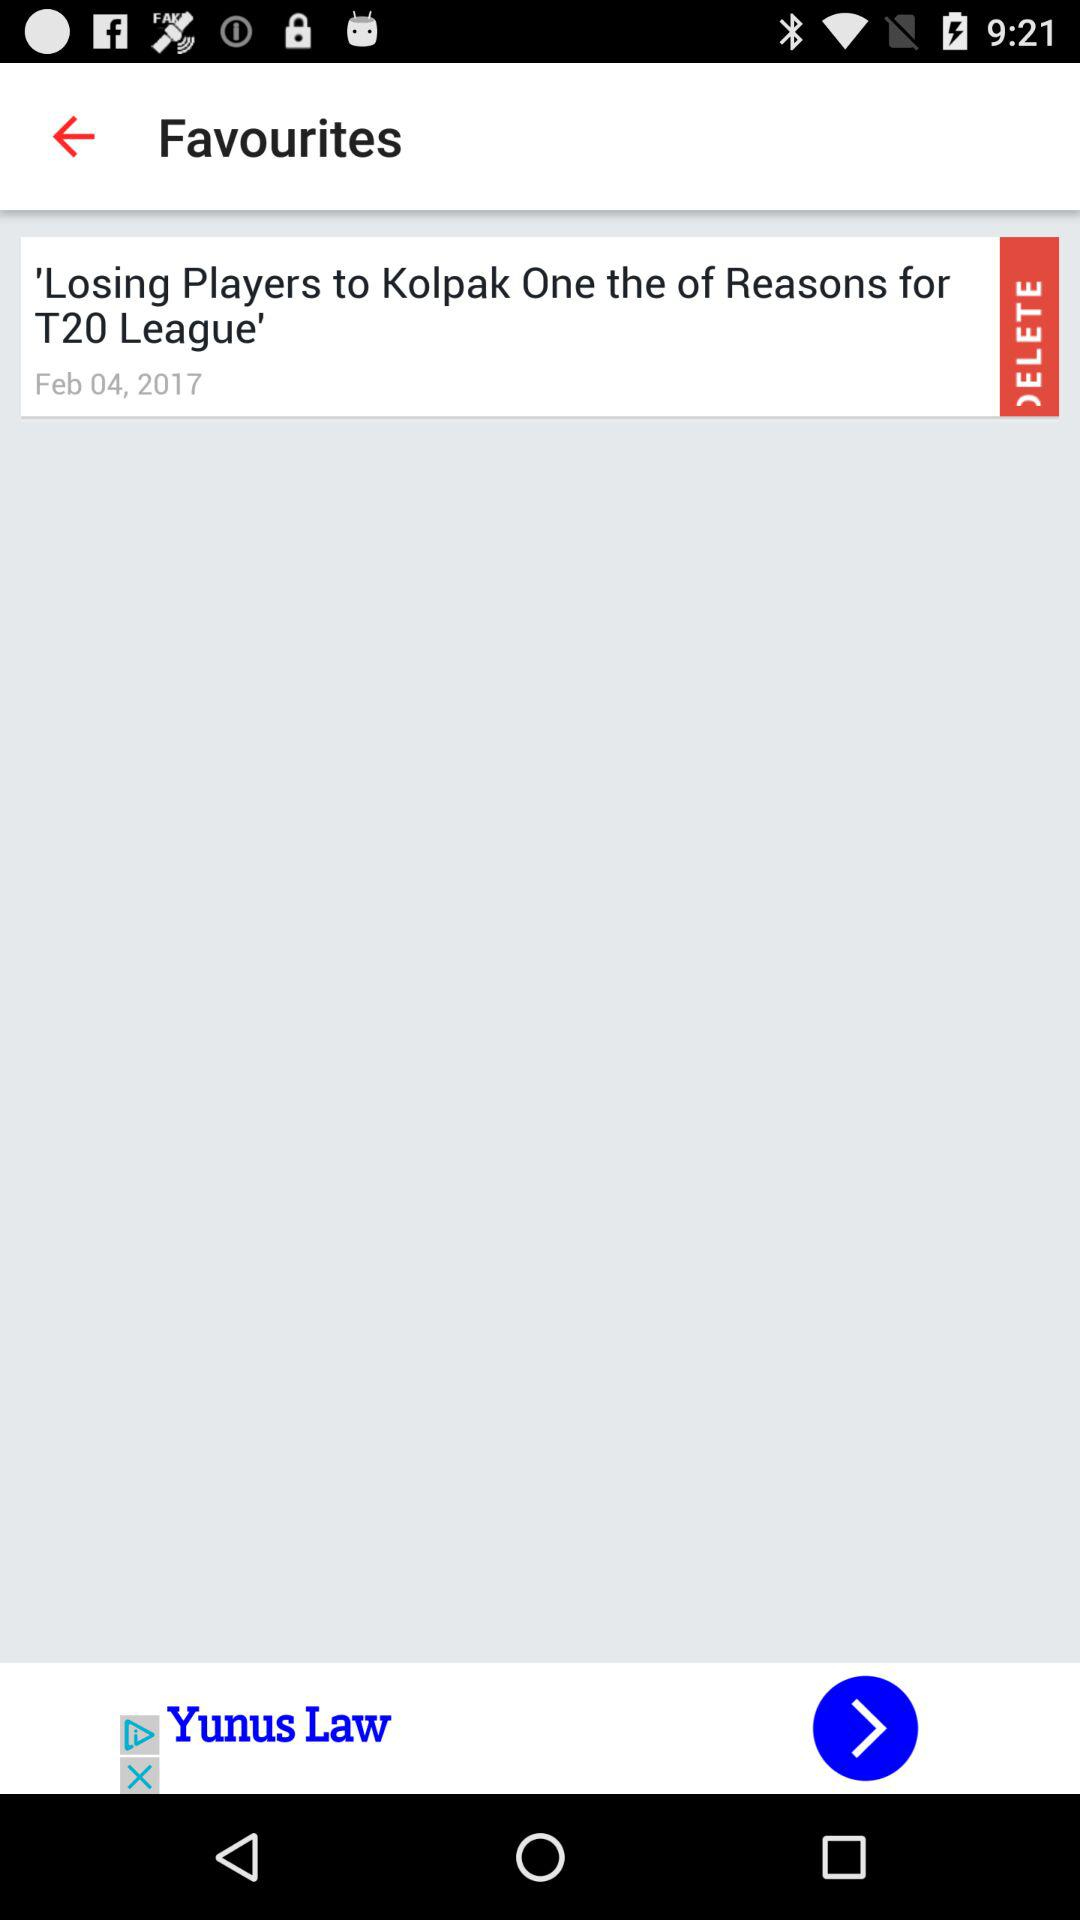What is the date for the title named "Losing Players to Kolpak One the of Reasons for T20 League"? The date is February 4, 2017. 